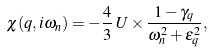<formula> <loc_0><loc_0><loc_500><loc_500>\chi ( { q } , i \omega _ { n } ) = - \frac { 4 } { 3 } \, U \times \frac { 1 - \gamma _ { q } } { \omega _ { n } ^ { 2 } + \epsilon _ { q } ^ { 2 } } ,</formula> 